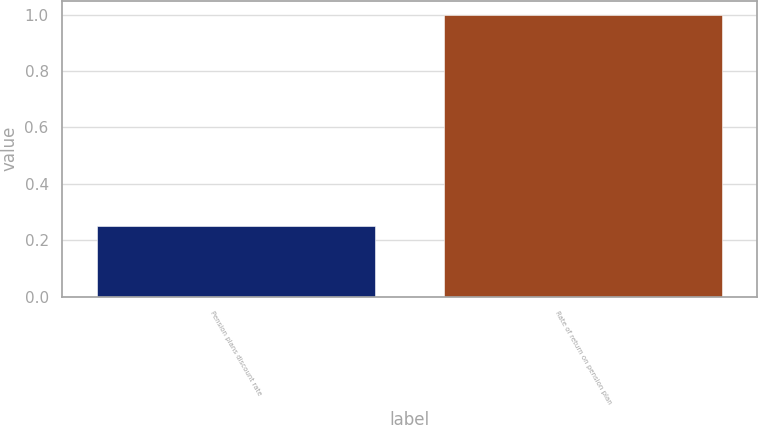Convert chart to OTSL. <chart><loc_0><loc_0><loc_500><loc_500><bar_chart><fcel>Pension plans discount rate<fcel>Rate of return on pension plan<nl><fcel>0.25<fcel>1<nl></chart> 